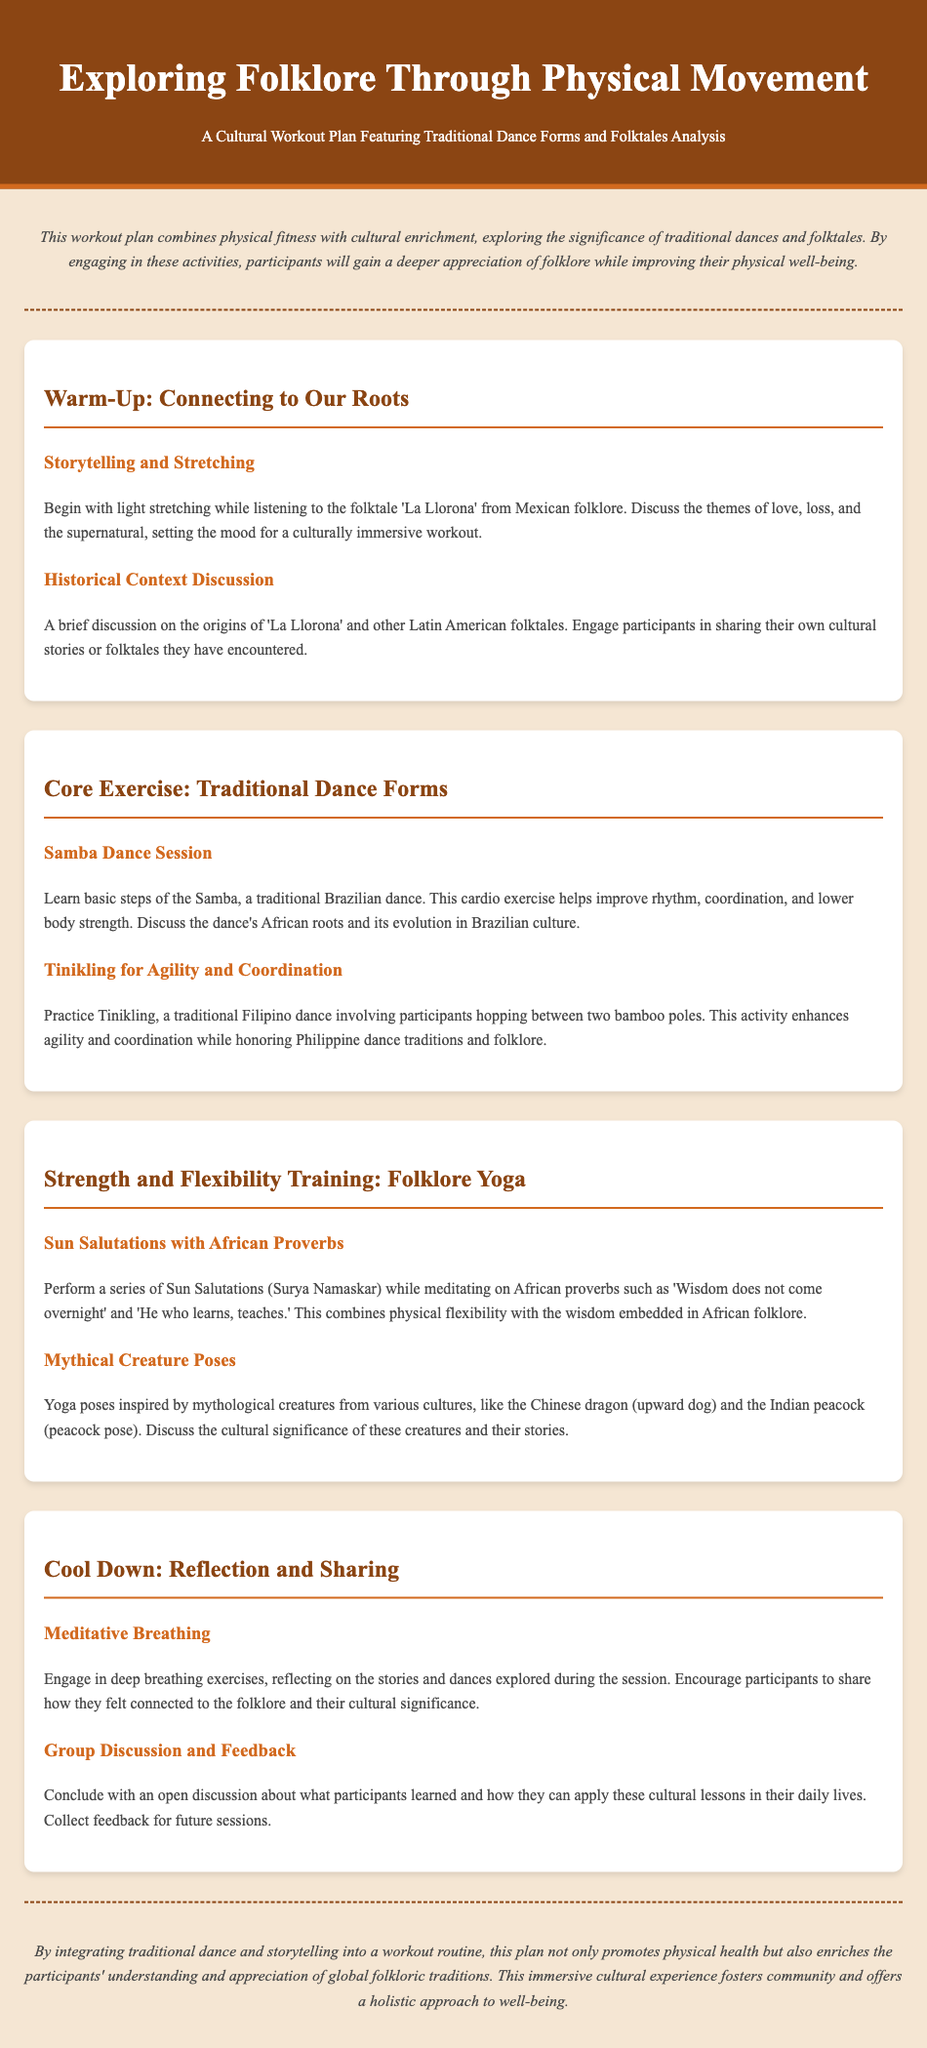What is the title of the workout plan? The title of the workout plan is displayed prominently at the top of the document.
Answer: Exploring Folklore Through Physical Movement What activity is associated with the folktale 'La Llorona'? This activity involves light stretching while listening to the folktale 'La Llorona'.
Answer: Storytelling and Stretching Which dance form is included in the core exercise section? The document lists specific dance forms under the core exercise section.
Answer: Samba Dance Session What cultural element does the Sun Salutations exercise incorporate? This exercise incorporates proverbs from African culture.
Answer: African Proverbs Which traditional dance involves bamboo poles? The document specifically describes a dance that uses bamboo poles.
Answer: Tinikling What is the purpose of the closing section of the workout plan? The closing section summarizes the experience and encourages sharing insights.
Answer: Reflection and Sharing How many exercises are mentioned in the Strength and Flexibility Training section? The document lists two activities under this section.
Answer: Two What is the final activity in the cool-down section? The final activity is where participants share their experiences and feedback.
Answer: Group Discussion and Feedback What underlying theme connects the activities in this workout plan? The activities are connected through the cultural significance of folklore.
Answer: Cultural enrichment 